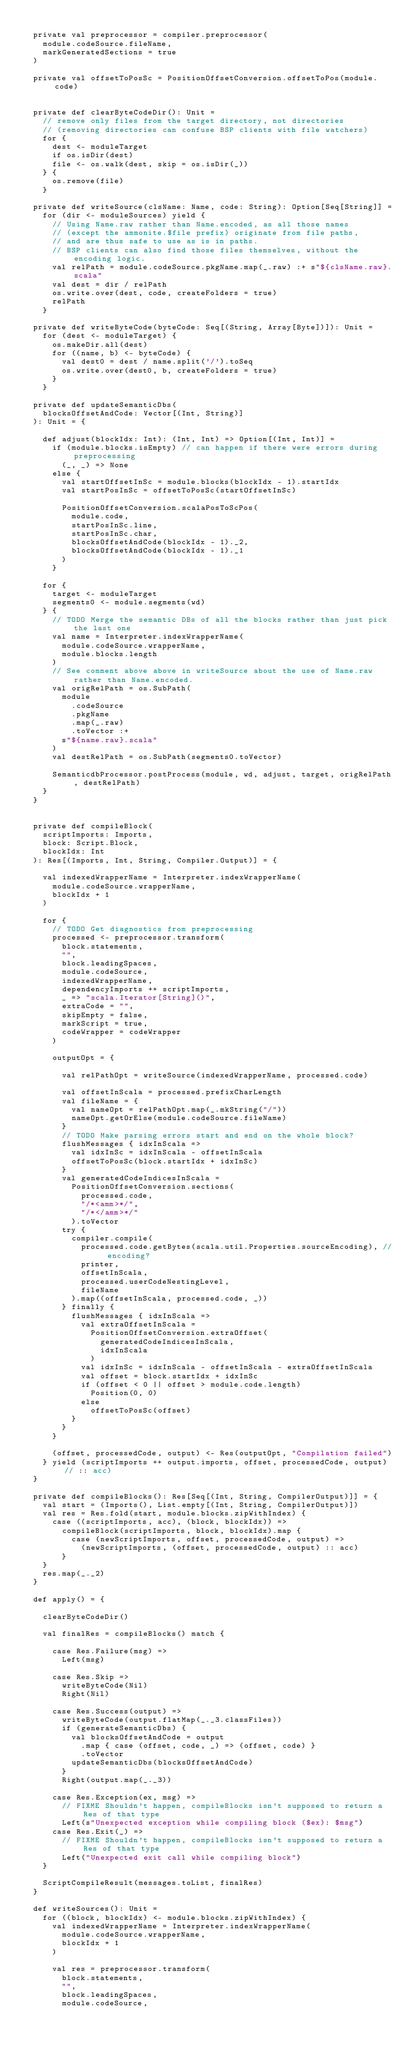Convert code to text. <code><loc_0><loc_0><loc_500><loc_500><_Scala_>
  private val preprocessor = compiler.preprocessor(
    module.codeSource.fileName,
    markGeneratedSections = true
  )

  private val offsetToPosSc = PositionOffsetConversion.offsetToPos(module.code)


  private def clearByteCodeDir(): Unit =
    // remove only files from the target directory, not directories
    // (removing directories can confuse BSP clients with file watchers)
    for {
      dest <- moduleTarget
      if os.isDir(dest)
      file <- os.walk(dest, skip = os.isDir(_))
    } {
      os.remove(file)
    }

  private def writeSource(clsName: Name, code: String): Option[Seq[String]] =
    for (dir <- moduleSources) yield {
      // Using Name.raw rather than Name.encoded, as all those names
      // (except the ammonite.$file prefix) originate from file paths,
      // and are thus safe to use as is in paths.
      // BSP clients can also find those files themselves, without the encoding logic.
      val relPath = module.codeSource.pkgName.map(_.raw) :+ s"${clsName.raw}.scala"
      val dest = dir / relPath
      os.write.over(dest, code, createFolders = true)
      relPath
    }

  private def writeByteCode(byteCode: Seq[(String, Array[Byte])]): Unit =
    for (dest <- moduleTarget) {
      os.makeDir.all(dest)
      for ((name, b) <- byteCode) {
        val dest0 = dest / name.split('/').toSeq
        os.write.over(dest0, b, createFolders = true)
      }
    }

  private def updateSemanticDbs(
    blocksOffsetAndCode: Vector[(Int, String)]
  ): Unit = {

    def adjust(blockIdx: Int): (Int, Int) => Option[(Int, Int)] =
      if (module.blocks.isEmpty) // can happen if there were errors during preprocessing
        (_, _) => None
      else {
        val startOffsetInSc = module.blocks(blockIdx - 1).startIdx
        val startPosInSc = offsetToPosSc(startOffsetInSc)

        PositionOffsetConversion.scalaPosToScPos(
          module.code,
          startPosInSc.line,
          startPosInSc.char,
          blocksOffsetAndCode(blockIdx - 1)._2,
          blocksOffsetAndCode(blockIdx - 1)._1
        )
      }

    for {
      target <- moduleTarget
      segments0 <- module.segments(wd)
    } {
      // TODO Merge the semantic DBs of all the blocks rather than just pick the last one
      val name = Interpreter.indexWrapperName(
        module.codeSource.wrapperName,
        module.blocks.length
      )
      // See comment above above in writeSource about the use of Name.raw rather than Name.encoded.
      val origRelPath = os.SubPath(
        module
          .codeSource
          .pkgName
          .map(_.raw)
          .toVector :+
        s"${name.raw}.scala"
      )
      val destRelPath = os.SubPath(segments0.toVector)

      SemanticdbProcessor.postProcess(module, wd, adjust, target, origRelPath, destRelPath)
    }
  }


  private def compileBlock(
    scriptImports: Imports,
    block: Script.Block,
    blockIdx: Int
  ): Res[(Imports, Int, String, Compiler.Output)] = {

    val indexedWrapperName = Interpreter.indexWrapperName(
      module.codeSource.wrapperName,
      blockIdx + 1
    )

    for {
      // TODO Get diagnostics from preprocessing
      processed <- preprocessor.transform(
        block.statements,
        "",
        block.leadingSpaces,
        module.codeSource,
        indexedWrapperName,
        dependencyImports ++ scriptImports,
        _ => "scala.Iterator[String]()",
        extraCode = "",
        skipEmpty = false,
        markScript = true,
        codeWrapper = codeWrapper
      )

      outputOpt = {

        val relPathOpt = writeSource(indexedWrapperName, processed.code)

        val offsetInScala = processed.prefixCharLength
        val fileName = {
          val nameOpt = relPathOpt.map(_.mkString("/"))
          nameOpt.getOrElse(module.codeSource.fileName)
        }
        // TODO Make parsing errors start and end on the whole block?
        flushMessages { idxInScala =>
          val idxInSc = idxInScala - offsetInScala
          offsetToPosSc(block.startIdx + idxInSc)
        }
        val generatedCodeIndicesInScala =
          PositionOffsetConversion.sections(
            processed.code,
            "/*<amm>*/",
            "/*</amm>*/"
          ).toVector
        try {
          compiler.compile(
            processed.code.getBytes(scala.util.Properties.sourceEncoding), // encoding?
            printer,
            offsetInScala,
            processed.userCodeNestingLevel,
            fileName
          ).map((offsetInScala, processed.code, _))
        } finally {
          flushMessages { idxInScala =>
            val extraOffsetInScala =
              PositionOffsetConversion.extraOffset(
                generatedCodeIndicesInScala,
                idxInScala
              )
            val idxInSc = idxInScala - offsetInScala - extraOffsetInScala
            val offset = block.startIdx + idxInSc
            if (offset < 0 || offset > module.code.length)
              Position(0, 0)
            else
              offsetToPosSc(offset)
          }
        }
      }

      (offset, processedCode, output) <- Res(outputOpt, "Compilation failed")
    } yield (scriptImports ++ output.imports, offset, processedCode, output) // :: acc)
  }

  private def compileBlocks(): Res[Seq[(Int, String, CompilerOutput)]] = {
    val start = (Imports(), List.empty[(Int, String, CompilerOutput)])
    val res = Res.fold(start, module.blocks.zipWithIndex) {
      case ((scriptImports, acc), (block, blockIdx)) =>
        compileBlock(scriptImports, block, blockIdx).map {
          case (newScriptImports, offset, processedCode, output) =>
            (newScriptImports, (offset, processedCode, output) :: acc)
        }
    }
    res.map(_._2)
  }

  def apply() = {

    clearByteCodeDir()

    val finalRes = compileBlocks() match {

      case Res.Failure(msg) =>
        Left(msg)

      case Res.Skip =>
        writeByteCode(Nil)
        Right(Nil)

      case Res.Success(output) =>
        writeByteCode(output.flatMap(_._3.classFiles))
        if (generateSemanticDbs) {
          val blocksOffsetAndCode = output
            .map { case (offset, code, _) => (offset, code) }
            .toVector
          updateSemanticDbs(blocksOffsetAndCode)
        }
        Right(output.map(_._3))

      case Res.Exception(ex, msg) =>
        // FIXME Shouldn't happen, compileBlocks isn't supposed to return a Res of that type
        Left(s"Unexpected exception while compiling block ($ex): $msg")
      case Res.Exit(_) =>
        // FIXME Shouldn't happen, compileBlocks isn't supposed to return a Res of that type
        Left("Unexpected exit call while compiling block")
    }

    ScriptCompileResult(messages.toList, finalRes)
  }

  def writeSources(): Unit =
    for ((block, blockIdx) <- module.blocks.zipWithIndex) {
      val indexedWrapperName = Interpreter.indexWrapperName(
        module.codeSource.wrapperName,
        blockIdx + 1
      )

      val res = preprocessor.transform(
        block.statements,
        "",
        block.leadingSpaces,
        module.codeSource,</code> 